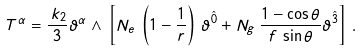Convert formula to latex. <formula><loc_0><loc_0><loc_500><loc_500>T ^ { \alpha } = \frac { \, k _ { 2 } } { 3 } \vartheta ^ { \alpha } \wedge \, \left [ N _ { e } \, \left ( 1 - \frac { 1 } { r } \right ) \, \vartheta ^ { \hat { 0 } } + N _ { g } \, \frac { 1 - \cos \theta } { f \, \sin \theta } \vartheta ^ { \hat { 3 } } \right ] \, .</formula> 